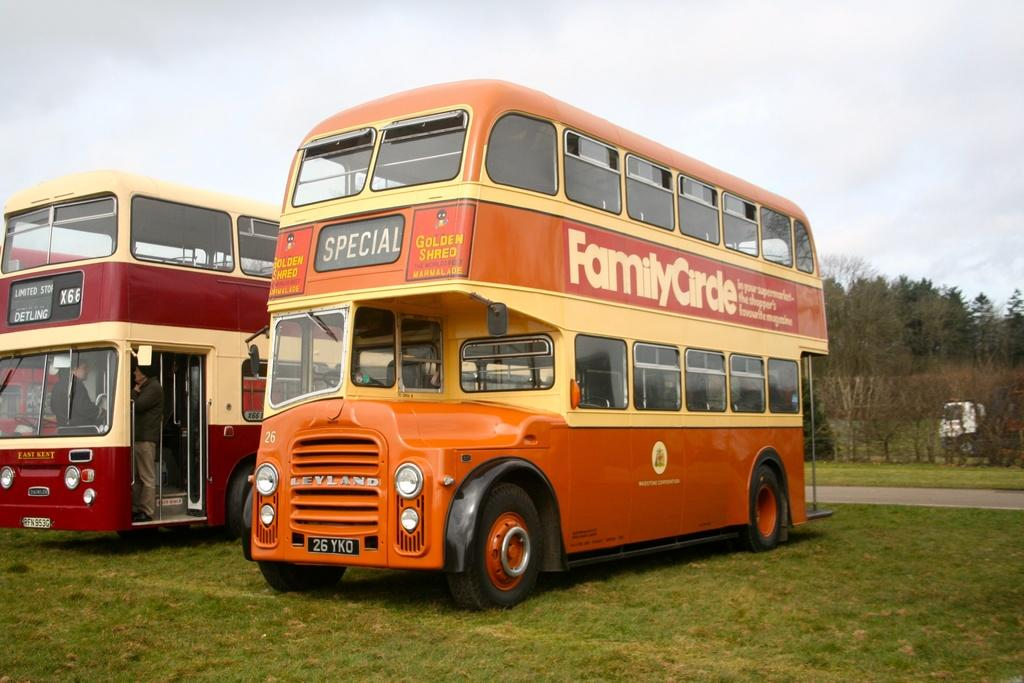Provide a one-sentence caption for the provided image. A yellow double decker bus has Family Circle written on the side. 